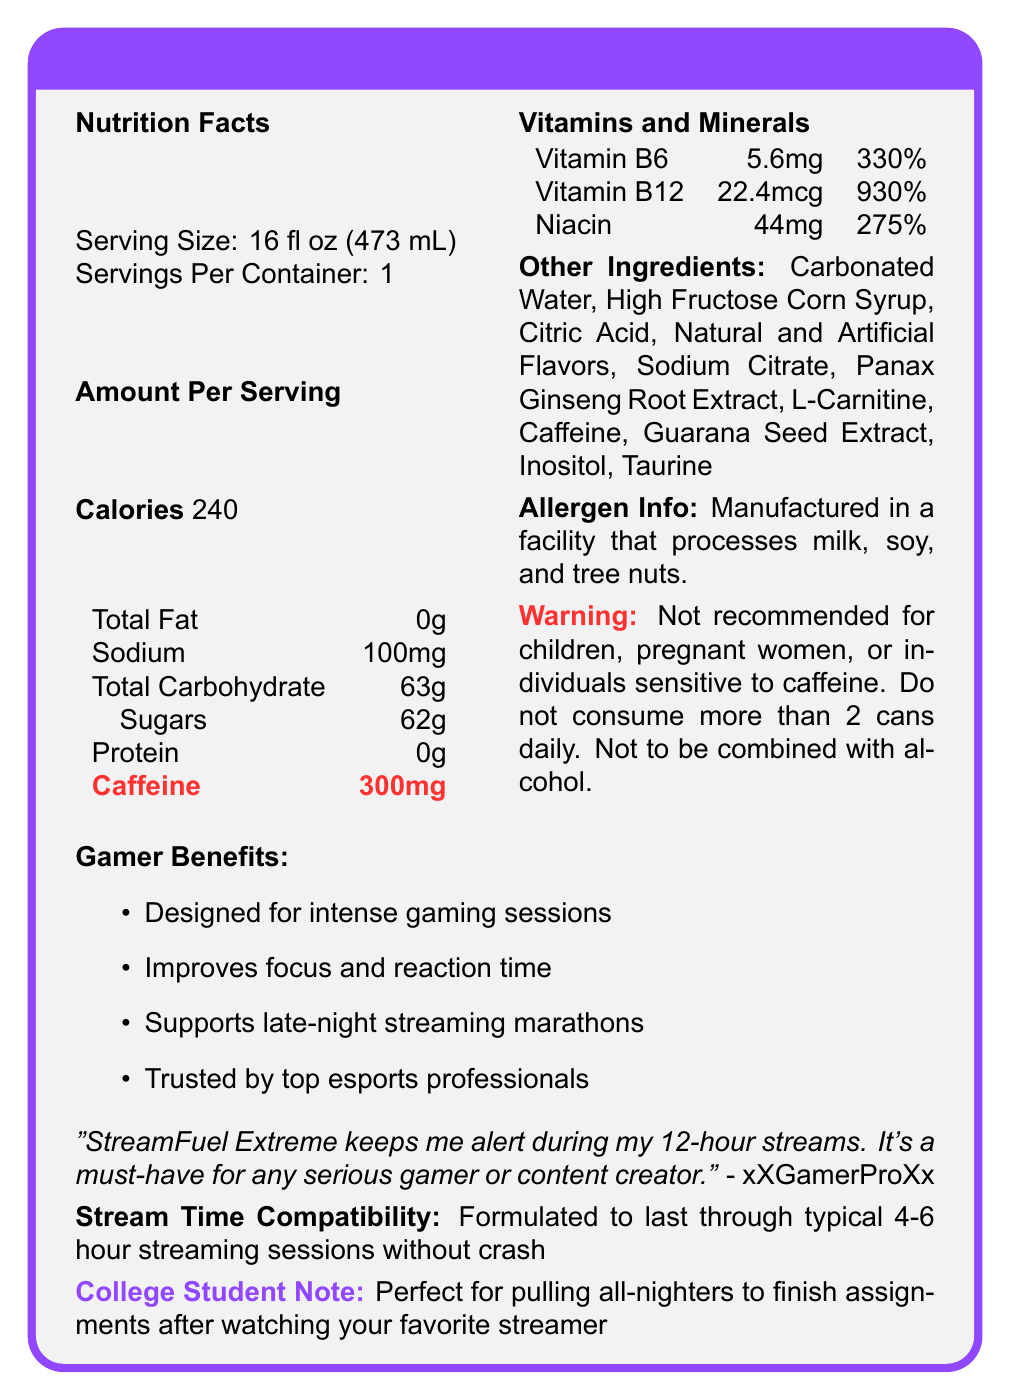what is the serving size of StreamFuel Extreme? The serving size is listed under "Nutrition Facts" as "Serving Size: 16 fl oz (473 mL)."
Answer: 16 fl oz (473 mL) how many calories are in one serving of StreamFuel Extreme? The "Amount Per Serving" section states "Calories 240."
Answer: 240 how much caffeine is in a single serving? This is detailed in the nutritional information table under "Caffeine."
Answer: 300mg what is the percentage of the daily value for Vitamin B6 in StreamFuel Extreme? The vitamins and minerals section shows "Vitamin B6: 5.6mg (330%)".
Answer: 330% which of the following ingredients is not listed in StreamFuel Extreme? A. Taurine B. L-Carnitine C. Aspartame D. Guarana Seed Extract Aspartame is not listed in the "Other Ingredients" section; the other options are all mentioned there.
Answer: C. Aspartame what are the marketing claims made about StreamFuel Extreme? A. Improves focus B. Enhances sleep C. Supports late-night streaming marathons D. Trusted by top esports professionals The marketing claims listed are "Designed for intense gaming sessions," "Improves focus and reaction time," "Supports late-night streaming marathons," and "Trusted by top esports professionals." Enhancing sleep is not mentioned.
Answer: B. Enhances sleep is StreamFuel Extreme recommended for children? The warning section specifically states that it is "Not recommended for children."
Answer: No is StreamFuel Extreme suitable for someone with tree nut allergies? The allergen info states that it is "Manufactured in a facility that processes milk, soy, and tree nuts."
Answer: No summarize the main focus of the StreamFuel Extreme document. The document provides comprehensive nutritional information, emphasizes the product's suitability for long gaming or streaming sessions, details its ingredients, and includes testimonials and marketing claims supporting its effectiveness.
Answer: StreamFuel Extreme is a high-caffeine energy drink designed for gamers to improve focus and endurance during long streaming sessions. It contains significant amounts of caffeine and vitamins like B6, B12, and Niacin. It includes a warning for certain individuals and emphasizes its performance benefits through marketing claims and testimonials. how much sugar does one serving of StreamFuel Extreme contain? The "Total Carbohydrate" section under "Sugars" specifies 62g.
Answer: 62g which vitamin has the highest percentage of daily value in StreamFuel Extreme? Vitamin B12 has a daily value percentage of 930%, which is the highest among the listed vitamins.
Answer: Vitamin B12 what should not be combined with StreamFuel Extreme according to the warning? A. Alcohol B. Other energy drinks C. Coffee D. Over-the-counter medications The warning states, "Not to be combined with alcohol."
Answer: A. Alcohol how many servings are in one container of StreamFuel Extreme? The nutritional information lists "Servings Per Container: 1."
Answer: 1 what benefit does xXGamerProXx mention in the testimonial? The testimonial by xXGamerProXx says, "StreamFuel Extreme keeps me alert during my 12-hour streams."
Answer: Keeps alert during 12-hour streams can you find the percentage of daily value for sodium in StreamFuel Extreme? The document does not provide the percentage of the daily value for sodium; it only lists the amount as "100mg."
Answer: Not enough information 